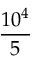Convert formula to latex. <formula><loc_0><loc_0><loc_500><loc_500>\frac { 1 0 ^ { 4 } } { 5 }</formula> 